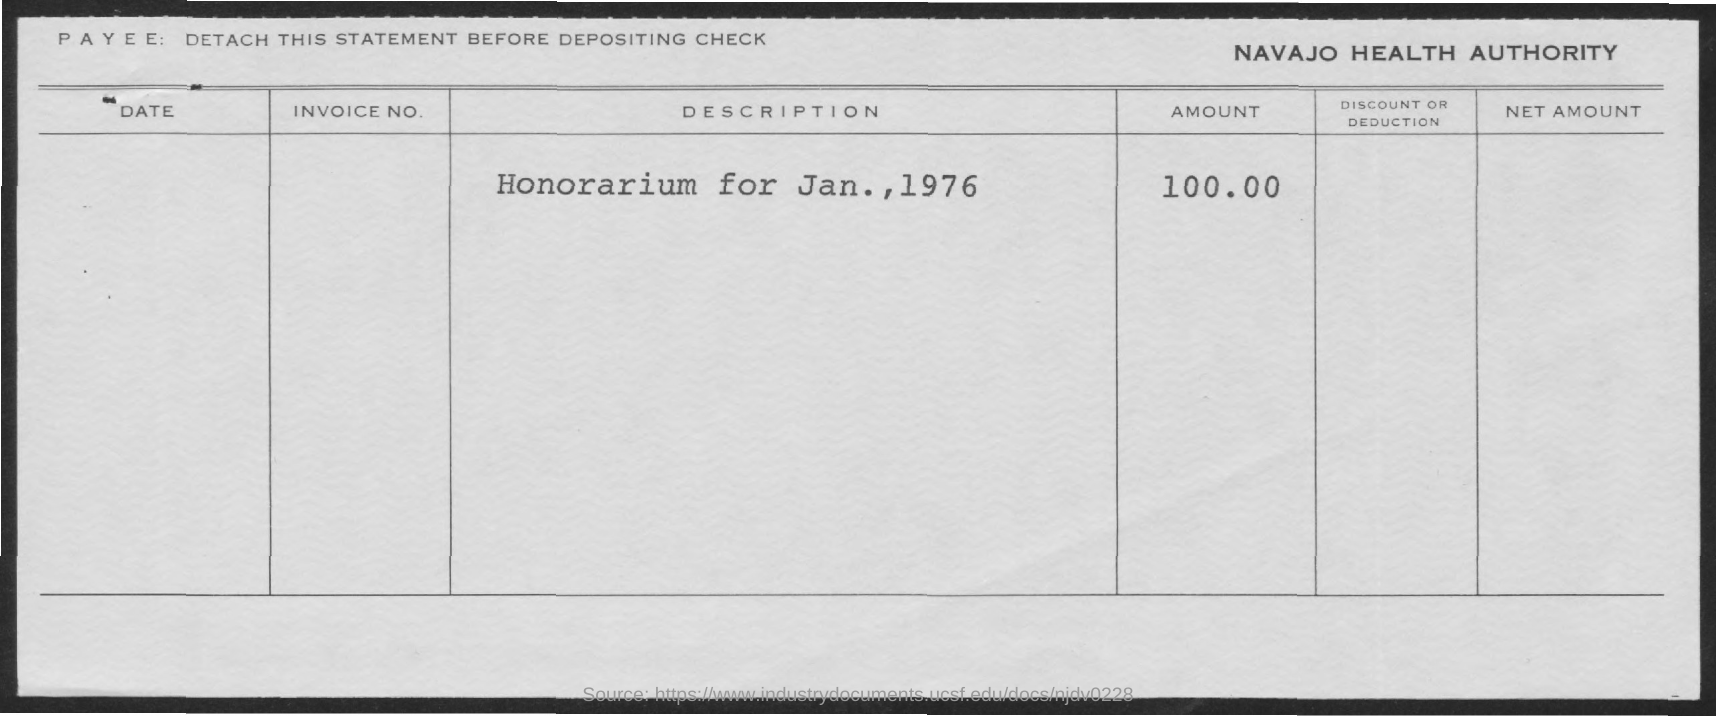What date is honorarium dated for?
Make the answer very short. Jan., 1976. What is the amount for honorarium?
Provide a short and direct response. $100.00. 